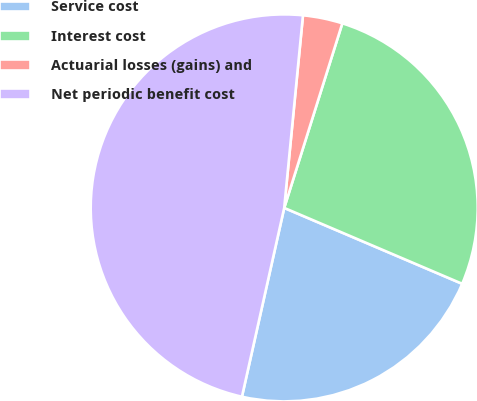<chart> <loc_0><loc_0><loc_500><loc_500><pie_chart><fcel>Service cost<fcel>Interest cost<fcel>Actuarial losses (gains) and<fcel>Net periodic benefit cost<nl><fcel>22.09%<fcel>26.56%<fcel>3.31%<fcel>48.04%<nl></chart> 